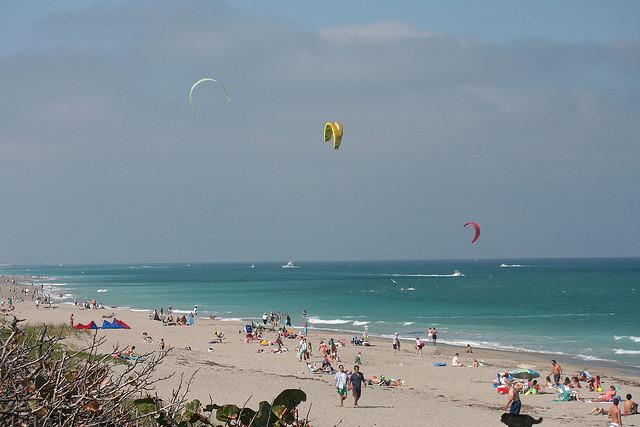Are the seas rough?
Short answer required. No. Hazy or sunny?
Be succinct. Hazy. What is in the sky?
Short answer required. Kites. 